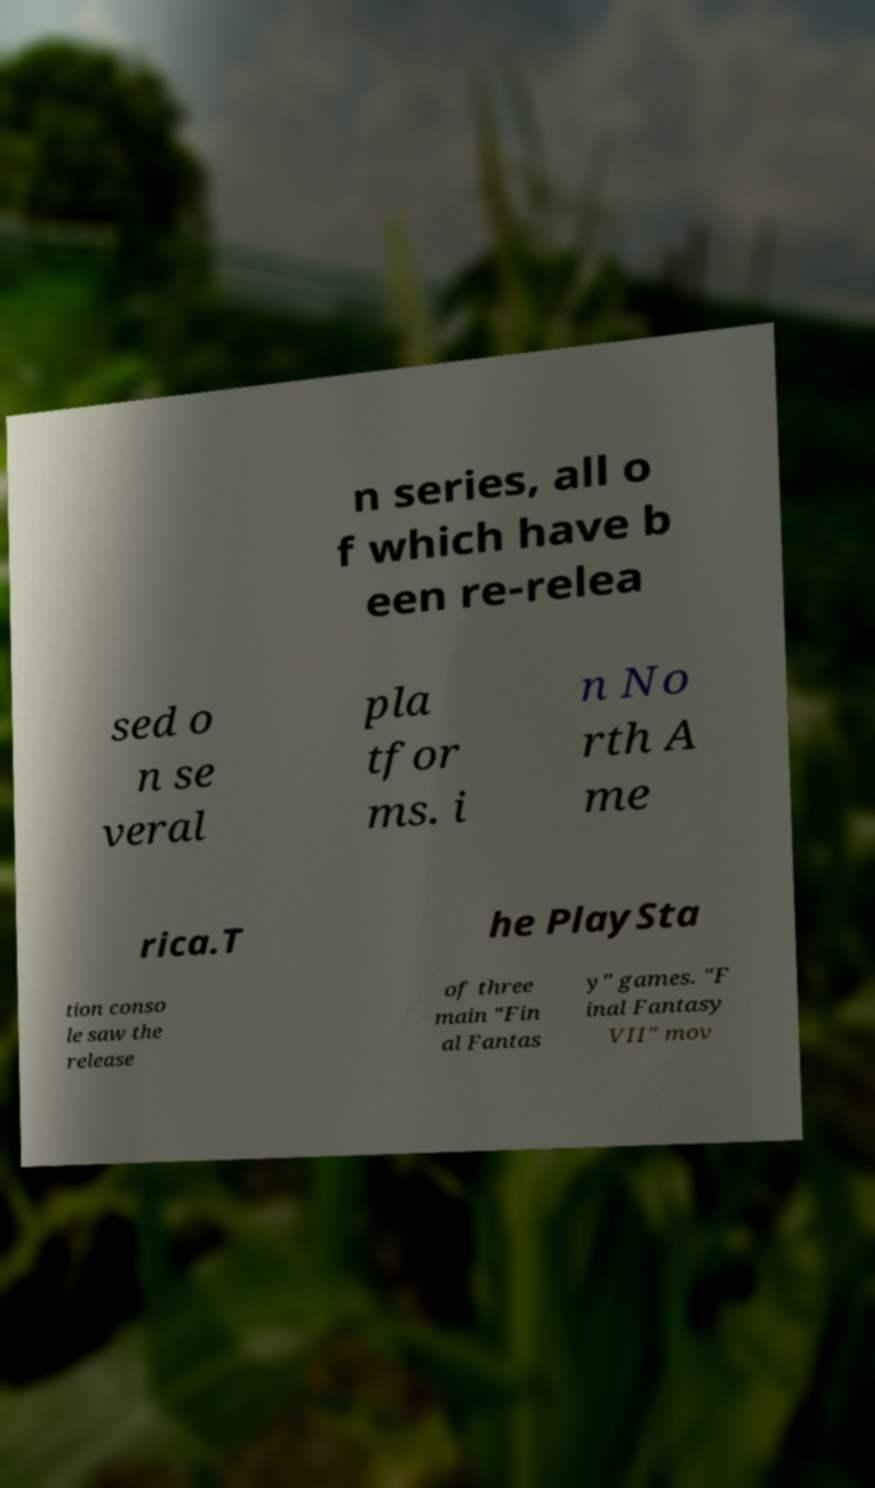I need the written content from this picture converted into text. Can you do that? n series, all o f which have b een re-relea sed o n se veral pla tfor ms. i n No rth A me rica.T he PlaySta tion conso le saw the release of three main "Fin al Fantas y" games. "F inal Fantasy VII" mov 